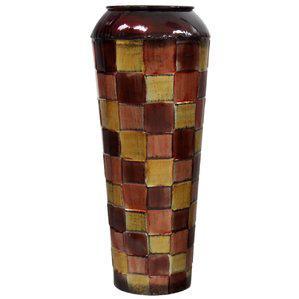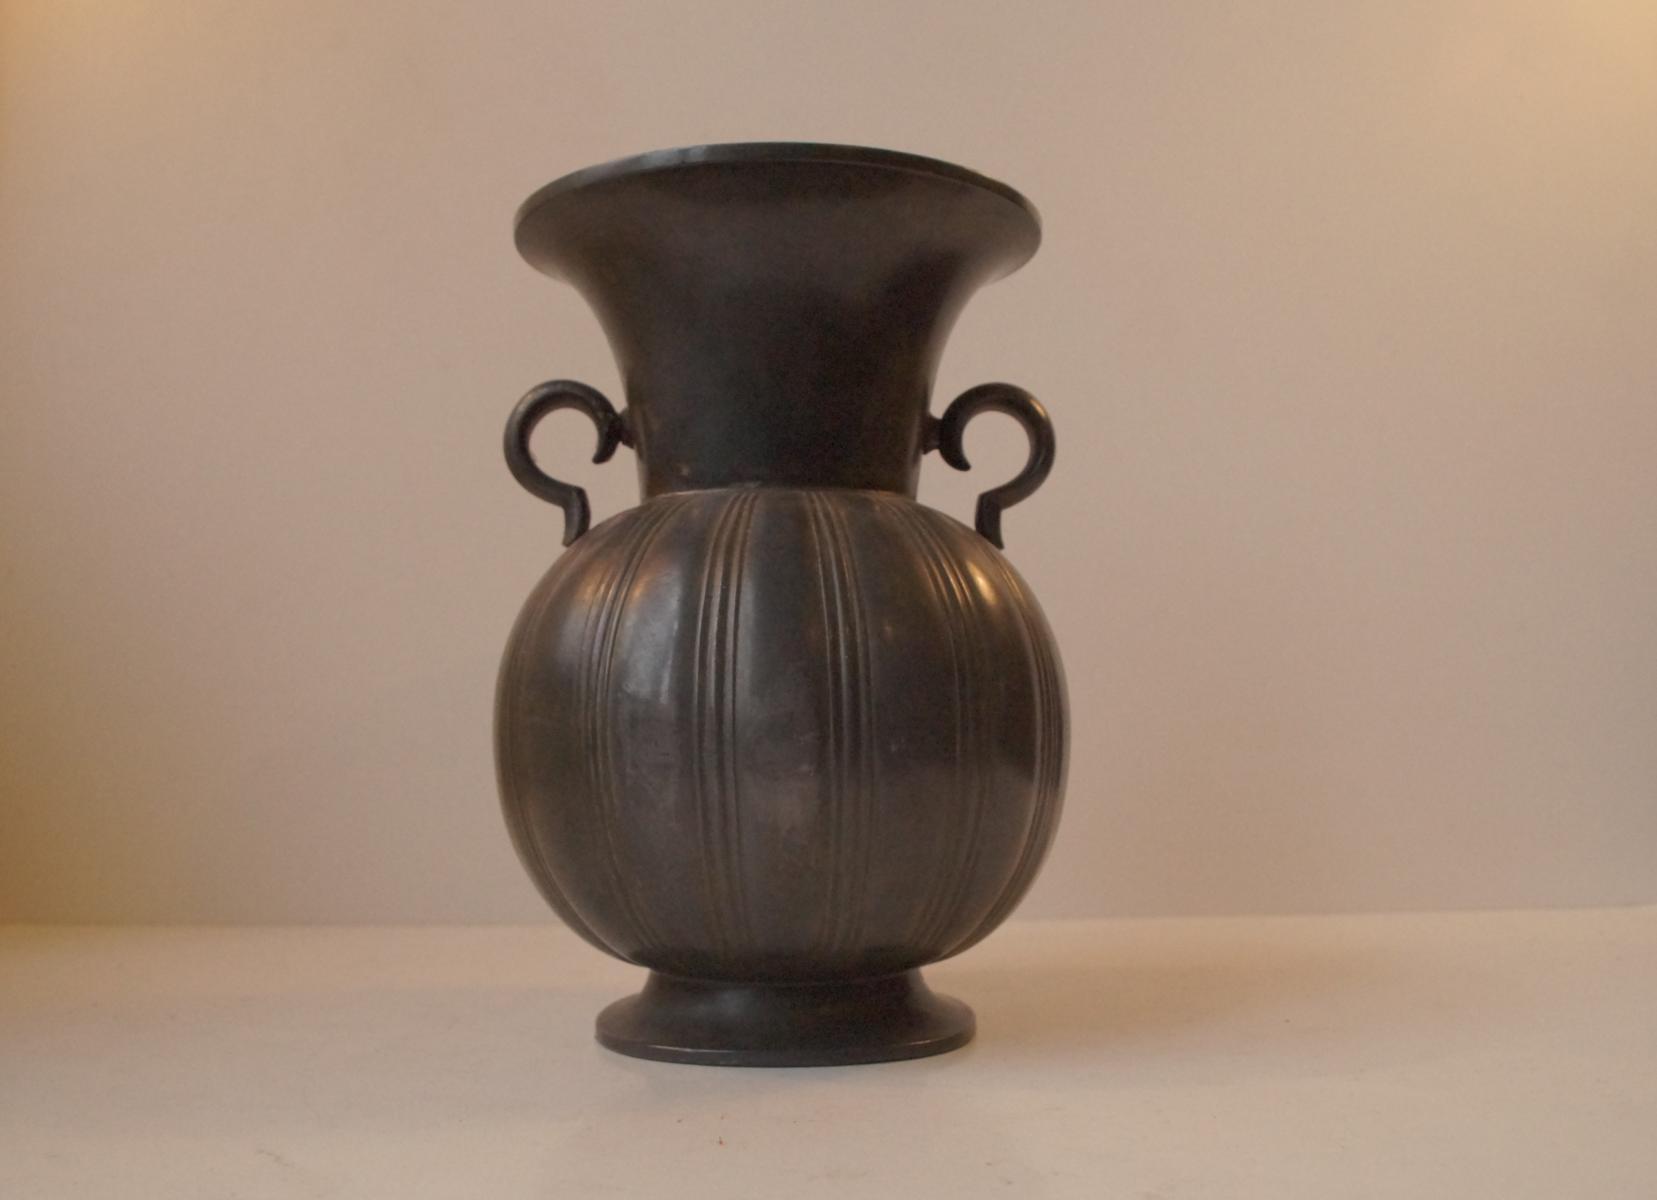The first image is the image on the left, the second image is the image on the right. Considering the images on both sides, is "There is an artistic ceramic vase with decorative patterns in the center of each image." valid? Answer yes or no. No. The first image is the image on the left, the second image is the image on the right. Given the left and right images, does the statement "In one image the vase has a square tip and in the other the vase has a convex body" hold true? Answer yes or no. No. 